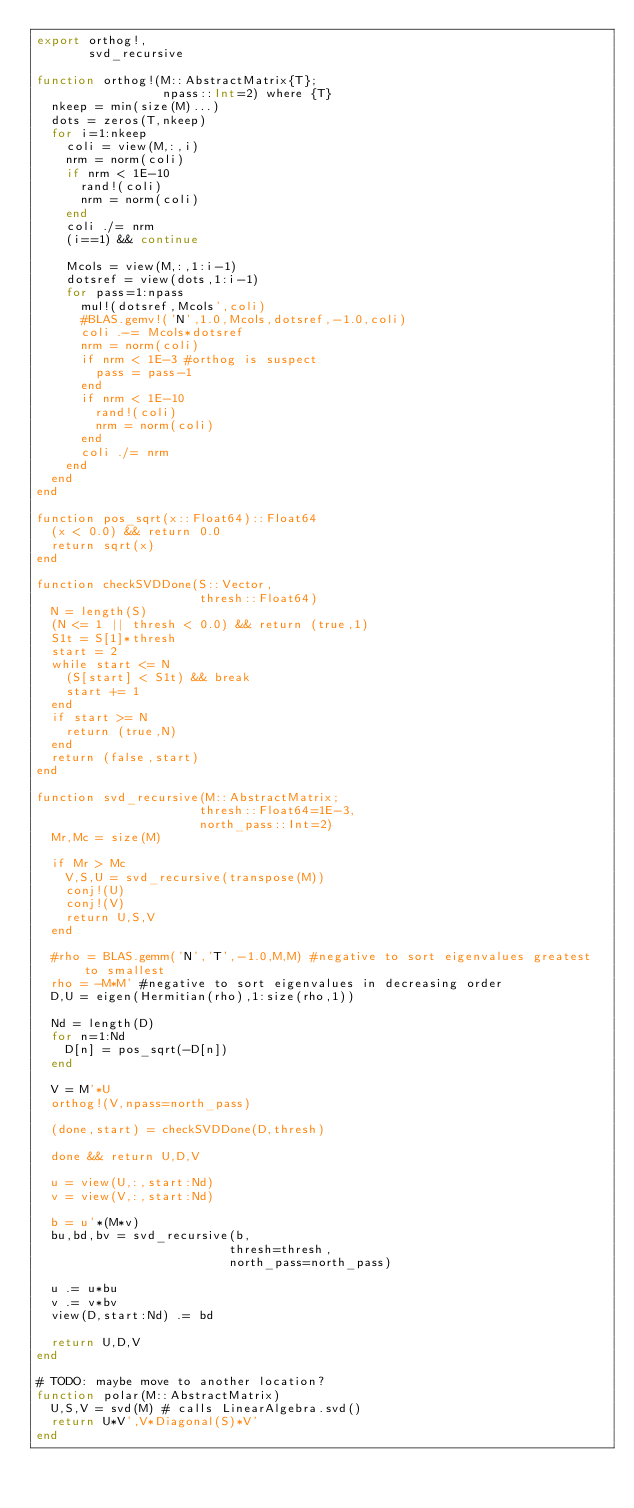Convert code to text. <code><loc_0><loc_0><loc_500><loc_500><_Julia_>export orthog!,
       svd_recursive

function orthog!(M::AbstractMatrix{T};
                 npass::Int=2) where {T}
  nkeep = min(size(M)...)
  dots = zeros(T,nkeep)
  for i=1:nkeep
    coli = view(M,:,i)
    nrm = norm(coli)
    if nrm < 1E-10
      rand!(coli)
      nrm = norm(coli)
    end
    coli ./= nrm
    (i==1) && continue

    Mcols = view(M,:,1:i-1)
    dotsref = view(dots,1:i-1)
    for pass=1:npass
      mul!(dotsref,Mcols',coli)
      #BLAS.gemv!('N',1.0,Mcols,dotsref,-1.0,coli)
      coli .-= Mcols*dotsref
      nrm = norm(coli)
      if nrm < 1E-3 #orthog is suspect
        pass = pass-1
      end
      if nrm < 1E-10
        rand!(coli)
        nrm = norm(coli)
      end
      coli ./= nrm
    end
  end
end

function pos_sqrt(x::Float64)::Float64
  (x < 0.0) && return 0.0
  return sqrt(x)
end

function checkSVDDone(S::Vector,
                      thresh::Float64)
  N = length(S)
  (N <= 1 || thresh < 0.0) && return (true,1)
  S1t = S[1]*thresh
  start = 2
  while start <= N
    (S[start] < S1t) && break
    start += 1
  end
  if start >= N
    return (true,N)
  end
  return (false,start)
end

function svd_recursive(M::AbstractMatrix;
                      thresh::Float64=1E-3,
                      north_pass::Int=2)
  Mr,Mc = size(M)

  if Mr > Mc
    V,S,U = svd_recursive(transpose(M))
    conj!(U)
    conj!(V)
    return U,S,V
  end

  #rho = BLAS.gemm('N','T',-1.0,M,M) #negative to sort eigenvalues greatest to smallest
  rho = -M*M' #negative to sort eigenvalues in decreasing order
  D,U = eigen(Hermitian(rho),1:size(rho,1))

  Nd = length(D)
  for n=1:Nd
    D[n] = pos_sqrt(-D[n])
  end

  V = M'*U
  orthog!(V,npass=north_pass)

  (done,start) = checkSVDDone(D,thresh)

  done && return U,D,V

  u = view(U,:,start:Nd)
  v = view(V,:,start:Nd)

  b = u'*(M*v)
  bu,bd,bv = svd_recursive(b,
                          thresh=thresh,
                          north_pass=north_pass)

  u .= u*bu
  v .= v*bv
  view(D,start:Nd) .= bd
  
  return U,D,V
end

# TODO: maybe move to another location?
function polar(M::AbstractMatrix)
  U,S,V = svd(M) # calls LinearAlgebra.svd()
  return U*V',V*Diagonal(S)*V'
end

</code> 